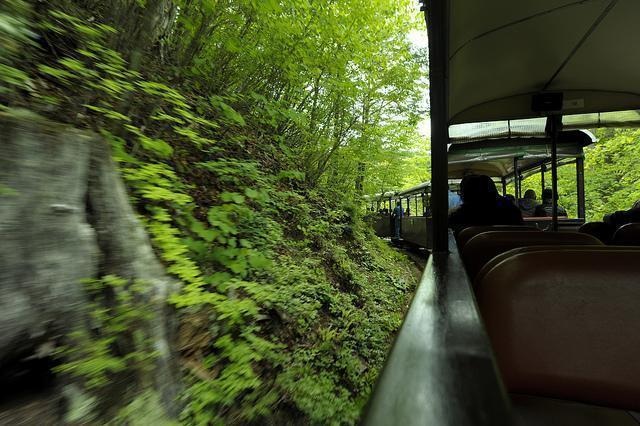If you stuck your hand out the side what would happen?
Indicate the correct choice and explain in the format: 'Answer: answer
Rationale: rationale.'
Options: Get electrocuted, touch people, touch cats, touch plants. Answer: touch plants.
Rationale: There is greenery lining the sides of the tracks and that is what would touch your fingers. 